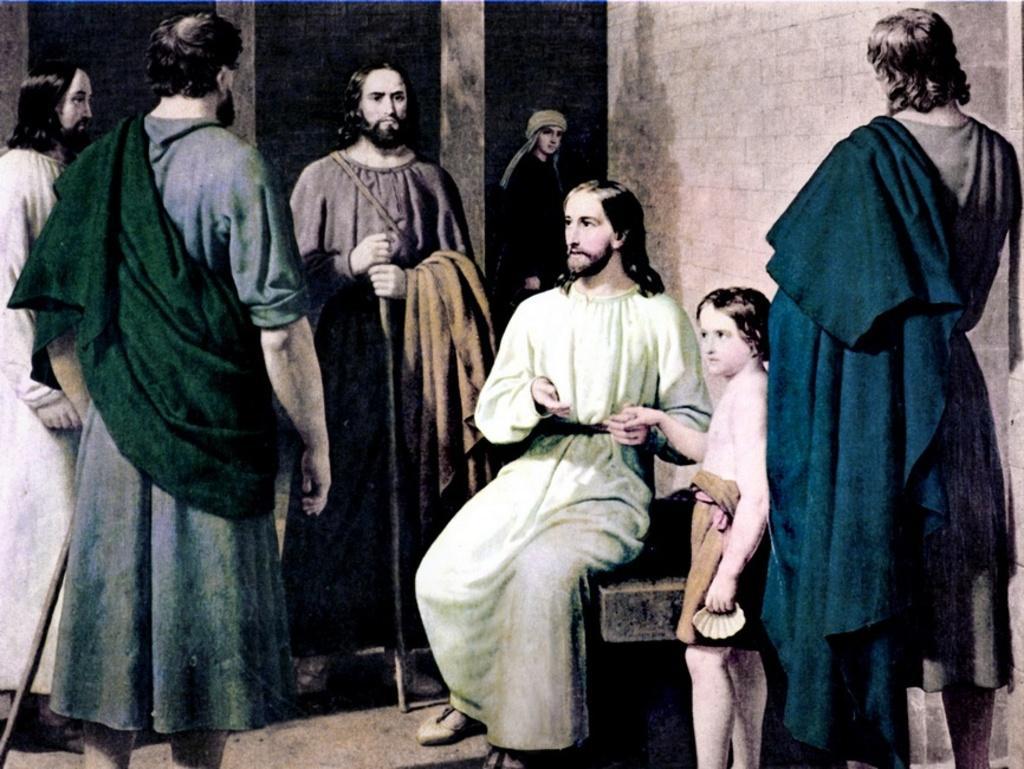Could you give a brief overview of what you see in this image? In this picture, it seems to be an animated image, there are people in the foreground area of the image and there are walls in the background area. 